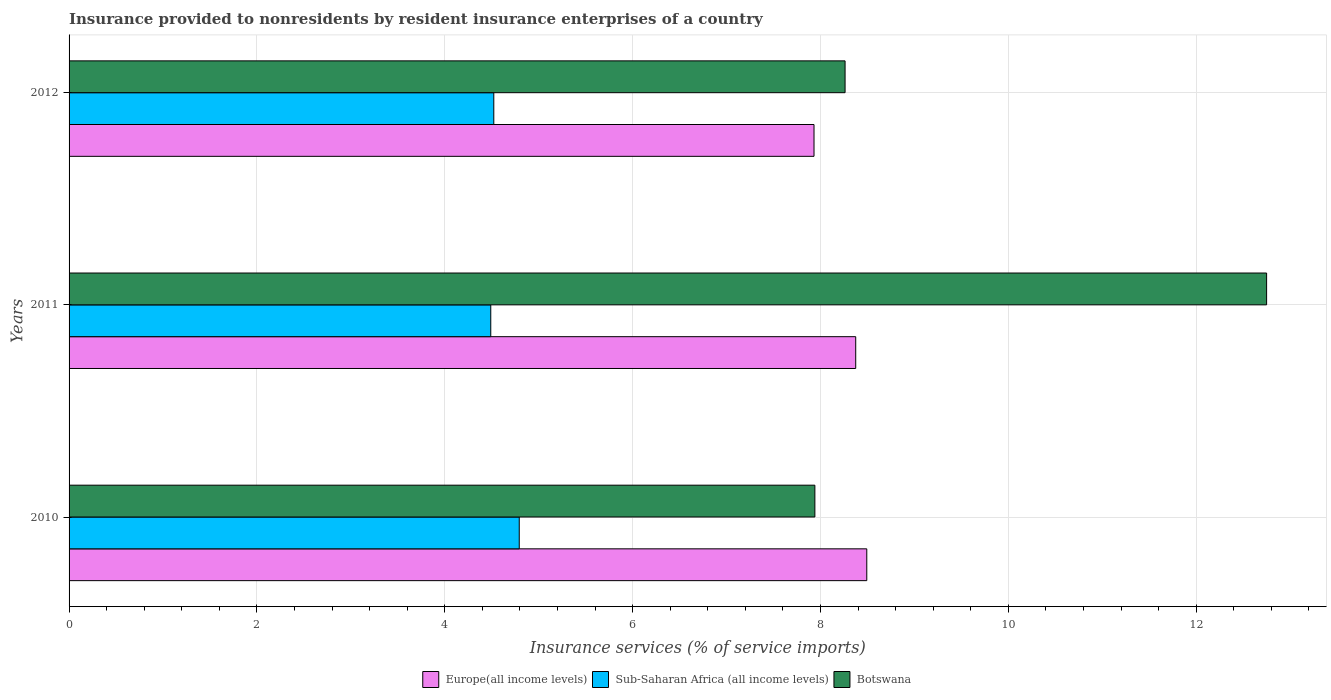How many groups of bars are there?
Provide a short and direct response. 3. Are the number of bars per tick equal to the number of legend labels?
Your answer should be very brief. Yes. Are the number of bars on each tick of the Y-axis equal?
Ensure brevity in your answer.  Yes. How many bars are there on the 3rd tick from the bottom?
Provide a succinct answer. 3. What is the insurance provided to nonresidents in Botswana in 2011?
Your response must be concise. 12.75. Across all years, what is the maximum insurance provided to nonresidents in Europe(all income levels)?
Keep it short and to the point. 8.49. Across all years, what is the minimum insurance provided to nonresidents in Sub-Saharan Africa (all income levels)?
Provide a short and direct response. 4.49. In which year was the insurance provided to nonresidents in Botswana maximum?
Your response must be concise. 2011. In which year was the insurance provided to nonresidents in Botswana minimum?
Offer a very short reply. 2010. What is the total insurance provided to nonresidents in Sub-Saharan Africa (all income levels) in the graph?
Give a very brief answer. 13.8. What is the difference between the insurance provided to nonresidents in Sub-Saharan Africa (all income levels) in 2010 and that in 2012?
Your answer should be very brief. 0.27. What is the difference between the insurance provided to nonresidents in Botswana in 2010 and the insurance provided to nonresidents in Sub-Saharan Africa (all income levels) in 2012?
Provide a succinct answer. 3.42. What is the average insurance provided to nonresidents in Europe(all income levels) per year?
Give a very brief answer. 8.27. In the year 2011, what is the difference between the insurance provided to nonresidents in Sub-Saharan Africa (all income levels) and insurance provided to nonresidents in Botswana?
Offer a very short reply. -8.26. In how many years, is the insurance provided to nonresidents in Sub-Saharan Africa (all income levels) greater than 4 %?
Offer a terse response. 3. What is the ratio of the insurance provided to nonresidents in Botswana in 2010 to that in 2011?
Your answer should be compact. 0.62. What is the difference between the highest and the second highest insurance provided to nonresidents in Botswana?
Your response must be concise. 4.49. What is the difference between the highest and the lowest insurance provided to nonresidents in Botswana?
Offer a very short reply. 4.81. In how many years, is the insurance provided to nonresidents in Europe(all income levels) greater than the average insurance provided to nonresidents in Europe(all income levels) taken over all years?
Keep it short and to the point. 2. What does the 1st bar from the top in 2010 represents?
Provide a succinct answer. Botswana. What does the 3rd bar from the bottom in 2011 represents?
Provide a short and direct response. Botswana. Are the values on the major ticks of X-axis written in scientific E-notation?
Give a very brief answer. No. How are the legend labels stacked?
Your answer should be very brief. Horizontal. What is the title of the graph?
Keep it short and to the point. Insurance provided to nonresidents by resident insurance enterprises of a country. Does "Zimbabwe" appear as one of the legend labels in the graph?
Your response must be concise. No. What is the label or title of the X-axis?
Your answer should be compact. Insurance services (% of service imports). What is the label or title of the Y-axis?
Keep it short and to the point. Years. What is the Insurance services (% of service imports) of Europe(all income levels) in 2010?
Keep it short and to the point. 8.49. What is the Insurance services (% of service imports) in Sub-Saharan Africa (all income levels) in 2010?
Offer a terse response. 4.79. What is the Insurance services (% of service imports) in Botswana in 2010?
Give a very brief answer. 7.94. What is the Insurance services (% of service imports) of Europe(all income levels) in 2011?
Ensure brevity in your answer.  8.37. What is the Insurance services (% of service imports) in Sub-Saharan Africa (all income levels) in 2011?
Ensure brevity in your answer.  4.49. What is the Insurance services (% of service imports) in Botswana in 2011?
Your response must be concise. 12.75. What is the Insurance services (% of service imports) in Europe(all income levels) in 2012?
Provide a short and direct response. 7.93. What is the Insurance services (% of service imports) of Sub-Saharan Africa (all income levels) in 2012?
Your answer should be very brief. 4.52. What is the Insurance services (% of service imports) in Botswana in 2012?
Provide a succinct answer. 8.26. Across all years, what is the maximum Insurance services (% of service imports) of Europe(all income levels)?
Make the answer very short. 8.49. Across all years, what is the maximum Insurance services (% of service imports) in Sub-Saharan Africa (all income levels)?
Provide a short and direct response. 4.79. Across all years, what is the maximum Insurance services (% of service imports) in Botswana?
Keep it short and to the point. 12.75. Across all years, what is the minimum Insurance services (% of service imports) in Europe(all income levels)?
Offer a very short reply. 7.93. Across all years, what is the minimum Insurance services (% of service imports) in Sub-Saharan Africa (all income levels)?
Give a very brief answer. 4.49. Across all years, what is the minimum Insurance services (% of service imports) in Botswana?
Make the answer very short. 7.94. What is the total Insurance services (% of service imports) in Europe(all income levels) in the graph?
Provide a short and direct response. 24.8. What is the total Insurance services (% of service imports) in Sub-Saharan Africa (all income levels) in the graph?
Provide a short and direct response. 13.8. What is the total Insurance services (% of service imports) of Botswana in the graph?
Offer a very short reply. 28.95. What is the difference between the Insurance services (% of service imports) of Europe(all income levels) in 2010 and that in 2011?
Provide a short and direct response. 0.12. What is the difference between the Insurance services (% of service imports) of Sub-Saharan Africa (all income levels) in 2010 and that in 2011?
Your response must be concise. 0.3. What is the difference between the Insurance services (% of service imports) in Botswana in 2010 and that in 2011?
Offer a terse response. -4.81. What is the difference between the Insurance services (% of service imports) of Europe(all income levels) in 2010 and that in 2012?
Your answer should be very brief. 0.56. What is the difference between the Insurance services (% of service imports) of Sub-Saharan Africa (all income levels) in 2010 and that in 2012?
Your response must be concise. 0.27. What is the difference between the Insurance services (% of service imports) in Botswana in 2010 and that in 2012?
Offer a terse response. -0.32. What is the difference between the Insurance services (% of service imports) of Europe(all income levels) in 2011 and that in 2012?
Your answer should be very brief. 0.44. What is the difference between the Insurance services (% of service imports) of Sub-Saharan Africa (all income levels) in 2011 and that in 2012?
Make the answer very short. -0.03. What is the difference between the Insurance services (% of service imports) in Botswana in 2011 and that in 2012?
Your response must be concise. 4.49. What is the difference between the Insurance services (% of service imports) of Europe(all income levels) in 2010 and the Insurance services (% of service imports) of Sub-Saharan Africa (all income levels) in 2011?
Your answer should be compact. 4. What is the difference between the Insurance services (% of service imports) of Europe(all income levels) in 2010 and the Insurance services (% of service imports) of Botswana in 2011?
Provide a succinct answer. -4.26. What is the difference between the Insurance services (% of service imports) in Sub-Saharan Africa (all income levels) in 2010 and the Insurance services (% of service imports) in Botswana in 2011?
Provide a succinct answer. -7.96. What is the difference between the Insurance services (% of service imports) of Europe(all income levels) in 2010 and the Insurance services (% of service imports) of Sub-Saharan Africa (all income levels) in 2012?
Offer a very short reply. 3.97. What is the difference between the Insurance services (% of service imports) of Europe(all income levels) in 2010 and the Insurance services (% of service imports) of Botswana in 2012?
Your answer should be very brief. 0.23. What is the difference between the Insurance services (% of service imports) of Sub-Saharan Africa (all income levels) in 2010 and the Insurance services (% of service imports) of Botswana in 2012?
Provide a succinct answer. -3.47. What is the difference between the Insurance services (% of service imports) in Europe(all income levels) in 2011 and the Insurance services (% of service imports) in Sub-Saharan Africa (all income levels) in 2012?
Your response must be concise. 3.85. What is the difference between the Insurance services (% of service imports) in Europe(all income levels) in 2011 and the Insurance services (% of service imports) in Botswana in 2012?
Your answer should be very brief. 0.11. What is the difference between the Insurance services (% of service imports) in Sub-Saharan Africa (all income levels) in 2011 and the Insurance services (% of service imports) in Botswana in 2012?
Offer a very short reply. -3.77. What is the average Insurance services (% of service imports) of Europe(all income levels) per year?
Keep it short and to the point. 8.27. What is the average Insurance services (% of service imports) in Sub-Saharan Africa (all income levels) per year?
Provide a succinct answer. 4.6. What is the average Insurance services (% of service imports) of Botswana per year?
Give a very brief answer. 9.65. In the year 2010, what is the difference between the Insurance services (% of service imports) of Europe(all income levels) and Insurance services (% of service imports) of Botswana?
Your response must be concise. 0.55. In the year 2010, what is the difference between the Insurance services (% of service imports) in Sub-Saharan Africa (all income levels) and Insurance services (% of service imports) in Botswana?
Give a very brief answer. -3.15. In the year 2011, what is the difference between the Insurance services (% of service imports) of Europe(all income levels) and Insurance services (% of service imports) of Sub-Saharan Africa (all income levels)?
Make the answer very short. 3.89. In the year 2011, what is the difference between the Insurance services (% of service imports) of Europe(all income levels) and Insurance services (% of service imports) of Botswana?
Ensure brevity in your answer.  -4.37. In the year 2011, what is the difference between the Insurance services (% of service imports) of Sub-Saharan Africa (all income levels) and Insurance services (% of service imports) of Botswana?
Provide a succinct answer. -8.26. In the year 2012, what is the difference between the Insurance services (% of service imports) of Europe(all income levels) and Insurance services (% of service imports) of Sub-Saharan Africa (all income levels)?
Offer a terse response. 3.41. In the year 2012, what is the difference between the Insurance services (% of service imports) in Europe(all income levels) and Insurance services (% of service imports) in Botswana?
Provide a succinct answer. -0.33. In the year 2012, what is the difference between the Insurance services (% of service imports) in Sub-Saharan Africa (all income levels) and Insurance services (% of service imports) in Botswana?
Offer a very short reply. -3.74. What is the ratio of the Insurance services (% of service imports) of Europe(all income levels) in 2010 to that in 2011?
Give a very brief answer. 1.01. What is the ratio of the Insurance services (% of service imports) of Sub-Saharan Africa (all income levels) in 2010 to that in 2011?
Provide a short and direct response. 1.07. What is the ratio of the Insurance services (% of service imports) of Botswana in 2010 to that in 2011?
Your answer should be very brief. 0.62. What is the ratio of the Insurance services (% of service imports) in Europe(all income levels) in 2010 to that in 2012?
Provide a short and direct response. 1.07. What is the ratio of the Insurance services (% of service imports) in Sub-Saharan Africa (all income levels) in 2010 to that in 2012?
Offer a terse response. 1.06. What is the ratio of the Insurance services (% of service imports) in Botswana in 2010 to that in 2012?
Make the answer very short. 0.96. What is the ratio of the Insurance services (% of service imports) of Europe(all income levels) in 2011 to that in 2012?
Provide a short and direct response. 1.06. What is the ratio of the Insurance services (% of service imports) of Botswana in 2011 to that in 2012?
Ensure brevity in your answer.  1.54. What is the difference between the highest and the second highest Insurance services (% of service imports) in Europe(all income levels)?
Make the answer very short. 0.12. What is the difference between the highest and the second highest Insurance services (% of service imports) of Sub-Saharan Africa (all income levels)?
Provide a succinct answer. 0.27. What is the difference between the highest and the second highest Insurance services (% of service imports) of Botswana?
Provide a short and direct response. 4.49. What is the difference between the highest and the lowest Insurance services (% of service imports) in Europe(all income levels)?
Your answer should be very brief. 0.56. What is the difference between the highest and the lowest Insurance services (% of service imports) of Sub-Saharan Africa (all income levels)?
Offer a very short reply. 0.3. What is the difference between the highest and the lowest Insurance services (% of service imports) of Botswana?
Provide a succinct answer. 4.81. 